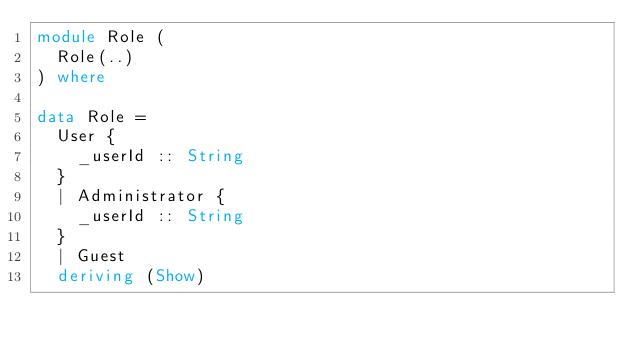<code> <loc_0><loc_0><loc_500><loc_500><_Haskell_>module Role (
  Role(..)
) where

data Role =
  User {
    _userId :: String
  }
  | Administrator {
    _userId :: String
  }
  | Guest
  deriving (Show)
</code> 